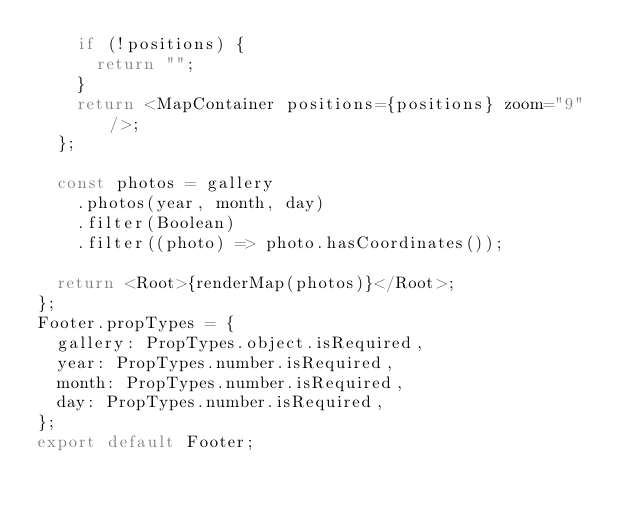Convert code to text. <code><loc_0><loc_0><loc_500><loc_500><_JavaScript_>    if (!positions) {
      return "";
    }
    return <MapContainer positions={positions} zoom="9" />;
  };

  const photos = gallery
    .photos(year, month, day)
    .filter(Boolean)
    .filter((photo) => photo.hasCoordinates());

  return <Root>{renderMap(photos)}</Root>;
};
Footer.propTypes = {
  gallery: PropTypes.object.isRequired,
  year: PropTypes.number.isRequired,
  month: PropTypes.number.isRequired,
  day: PropTypes.number.isRequired,
};
export default Footer;
</code> 